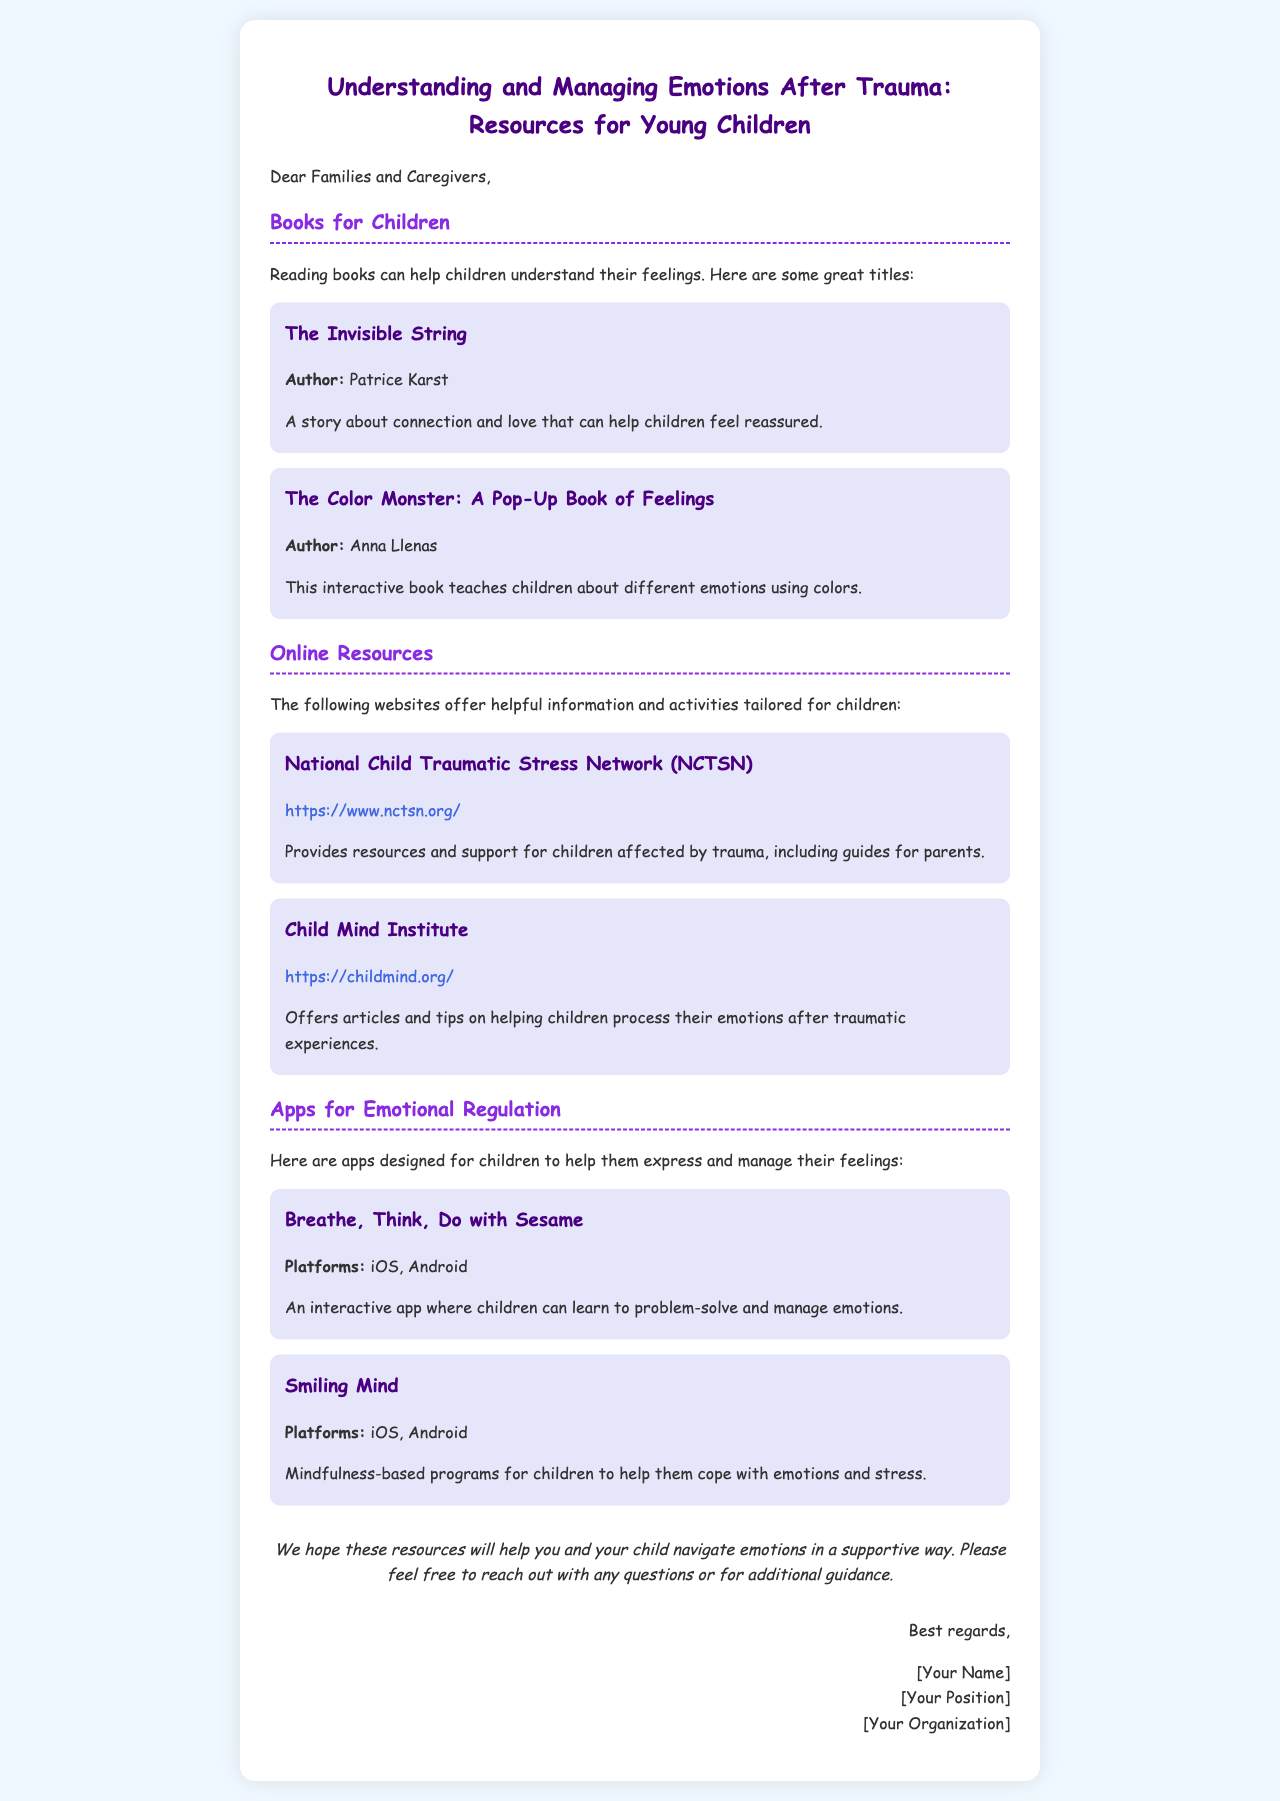what is the title of the email? The title of the email is located at the top of the document, summarizing the main theme.
Answer: Understanding and Managing Emotions After Trauma: Resources for Young Children who is the author of "The Invisible String"? The author of the book is mentioned within the resource section of the document.
Answer: Patrice Karst what is one of the apps mentioned for emotional regulation? The apps are listed under a specific section in the document.
Answer: Breathe, Think, Do with Sesame what does the Child Mind Institute offer? The offerings of the Child Mind Institute are detailed in its respective resource section.
Answer: Articles and tips on helping children process their emotions after traumatic experiences how many online resources are listed? The total count of online resources is determined by reviewing the two listed websites in the document.
Answer: 2 